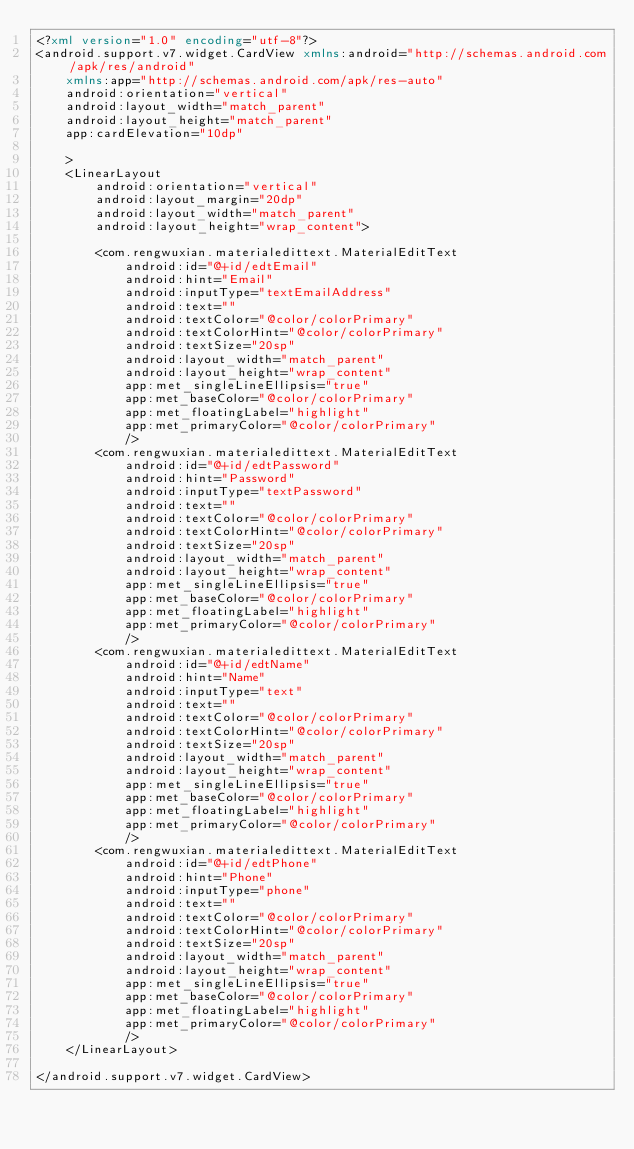Convert code to text. <code><loc_0><loc_0><loc_500><loc_500><_XML_><?xml version="1.0" encoding="utf-8"?>
<android.support.v7.widget.CardView xmlns:android="http://schemas.android.com/apk/res/android"
    xmlns:app="http://schemas.android.com/apk/res-auto"
    android:orientation="vertical"
    android:layout_width="match_parent"
    android:layout_height="match_parent"
    app:cardElevation="10dp"

    >
    <LinearLayout
        android:orientation="vertical"
        android:layout_margin="20dp"
        android:layout_width="match_parent"
        android:layout_height="wrap_content">

        <com.rengwuxian.materialedittext.MaterialEditText
            android:id="@+id/edtEmail"
            android:hint="Email"
            android:inputType="textEmailAddress"
            android:text=""
            android:textColor="@color/colorPrimary"
            android:textColorHint="@color/colorPrimary"
            android:textSize="20sp"
            android:layout_width="match_parent"
            android:layout_height="wrap_content"
            app:met_singleLineEllipsis="true"
            app:met_baseColor="@color/colorPrimary"
            app:met_floatingLabel="highlight"
            app:met_primaryColor="@color/colorPrimary"
            />
        <com.rengwuxian.materialedittext.MaterialEditText
            android:id="@+id/edtPassword"
            android:hint="Password"
            android:inputType="textPassword"
            android:text=""
            android:textColor="@color/colorPrimary"
            android:textColorHint="@color/colorPrimary"
            android:textSize="20sp"
            android:layout_width="match_parent"
            android:layout_height="wrap_content"
            app:met_singleLineEllipsis="true"
            app:met_baseColor="@color/colorPrimary"
            app:met_floatingLabel="highlight"
            app:met_primaryColor="@color/colorPrimary"
            />
        <com.rengwuxian.materialedittext.MaterialEditText
            android:id="@+id/edtName"
            android:hint="Name"
            android:inputType="text"
            android:text=""
            android:textColor="@color/colorPrimary"
            android:textColorHint="@color/colorPrimary"
            android:textSize="20sp"
            android:layout_width="match_parent"
            android:layout_height="wrap_content"
            app:met_singleLineEllipsis="true"
            app:met_baseColor="@color/colorPrimary"
            app:met_floatingLabel="highlight"
            app:met_primaryColor="@color/colorPrimary"
            />
        <com.rengwuxian.materialedittext.MaterialEditText
            android:id="@+id/edtPhone"
            android:hint="Phone"
            android:inputType="phone"
            android:text=""
            android:textColor="@color/colorPrimary"
            android:textColorHint="@color/colorPrimary"
            android:textSize="20sp"
            android:layout_width="match_parent"
            android:layout_height="wrap_content"
            app:met_singleLineEllipsis="true"
            app:met_baseColor="@color/colorPrimary"
            app:met_floatingLabel="highlight"
            app:met_primaryColor="@color/colorPrimary"
            />
    </LinearLayout>

</android.support.v7.widget.CardView></code> 